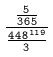<formula> <loc_0><loc_0><loc_500><loc_500>\frac { \frac { 5 } { 3 6 5 } } { \frac { 4 4 8 ^ { 1 1 9 } } { 3 } }</formula> 